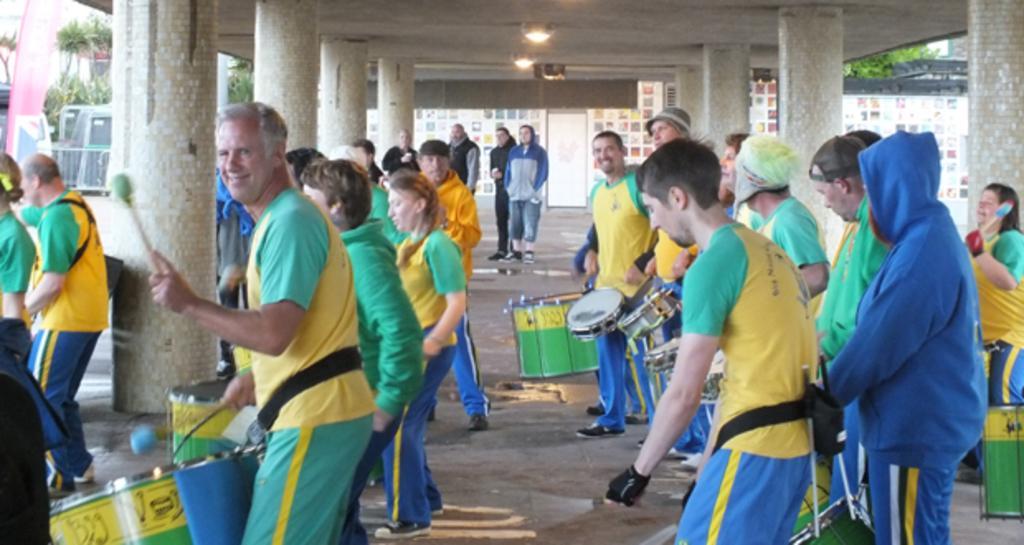Can you describe this image briefly? This picture describes about group of people, few people are playing drums, in the background we can see few pillars, lights and trees. 